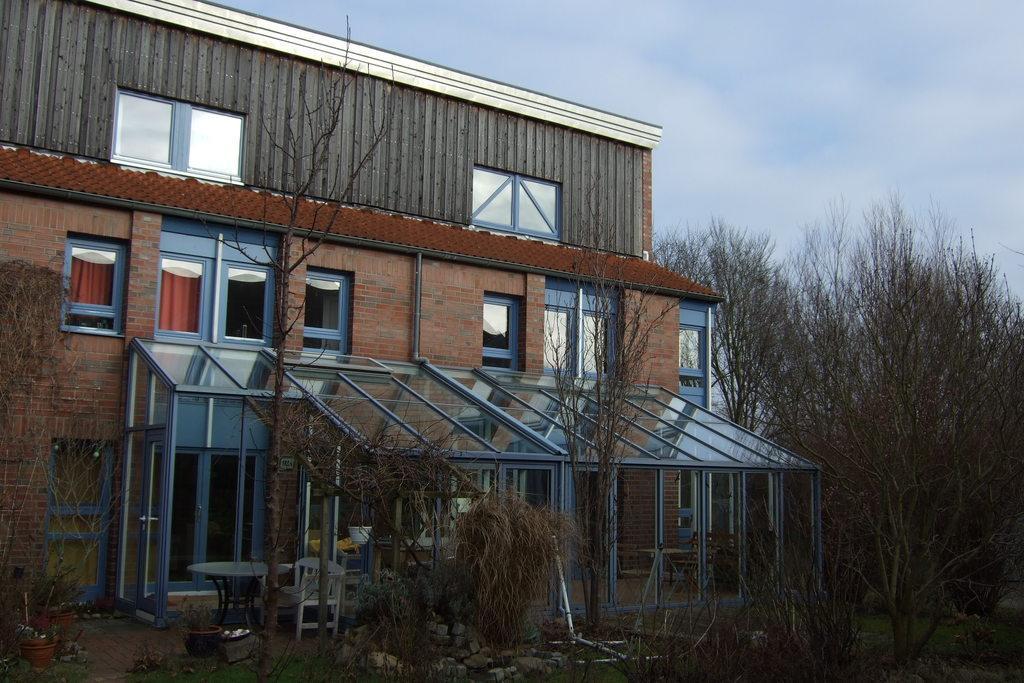How would you summarize this image in a sentence or two? In this picture I see the plants and trees in front and in the background I see a building and I see the sky and in the middle of this picture I see a chair. 